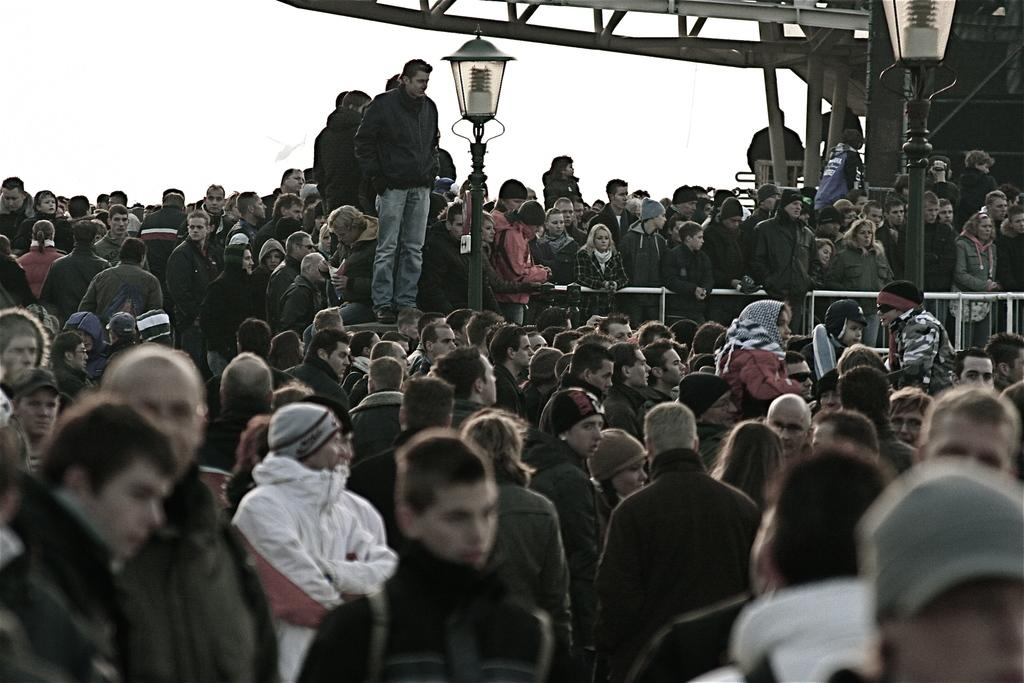What is the main subject of the image? The main subject of the image is a group of people standing. What structures can be seen in the background of the image? There are street poles and a metal fence in the image. What type of material are the poles made of? The poles in the image are made of metal. What type of powder is being used by the people in the image? There is no indication of any powder being used in the image. What language are the people in the image speaking? The language spoken by the people in the image cannot be determined from the image itself. 